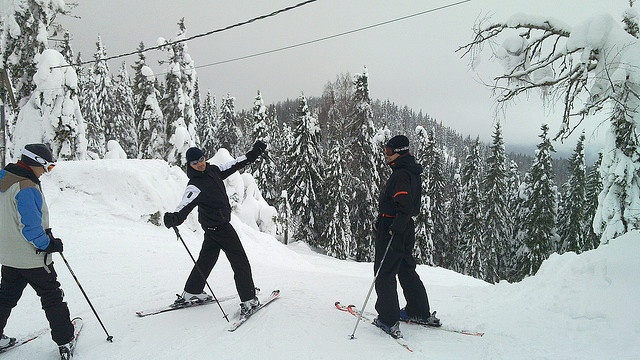Describe the objects in this image and their specific colors. I can see people in lightgray, black, darkgray, blue, and gray tones, people in lightgray, black, gray, and darkgray tones, people in lightgray, black, gray, and darkgray tones, skis in lightgray, darkgray, and black tones, and skis in lightgray, gray, darkgray, and black tones in this image. 